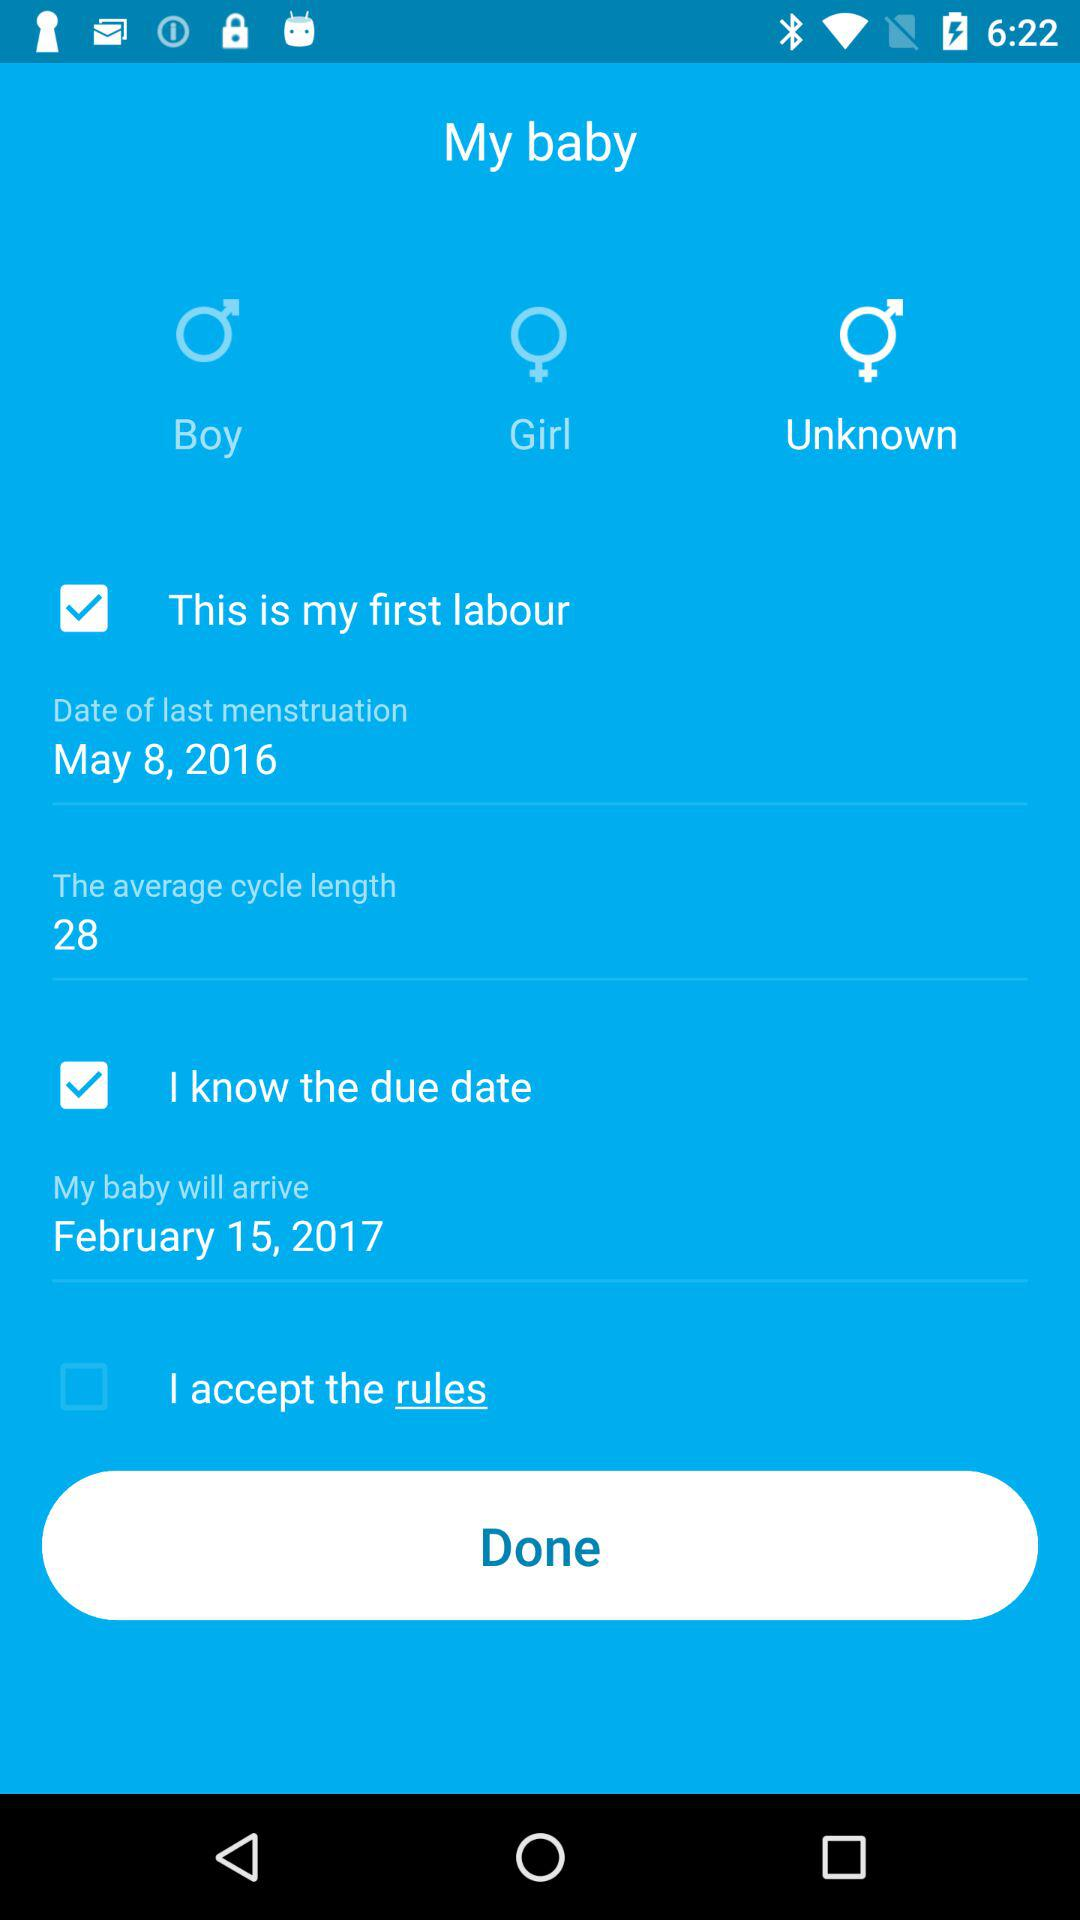How many days are in the average cycle length?
Answer the question using a single word or phrase. 28 